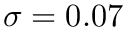Convert formula to latex. <formula><loc_0><loc_0><loc_500><loc_500>\sigma = 0 . 0 7</formula> 